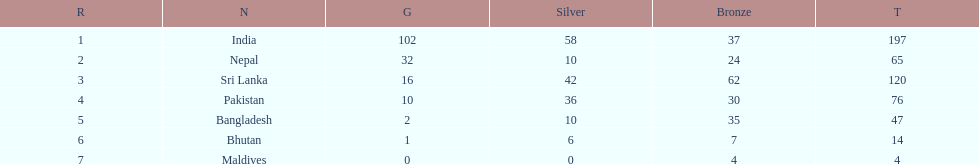How many gold medals were awarded between all 7 nations? 163. 